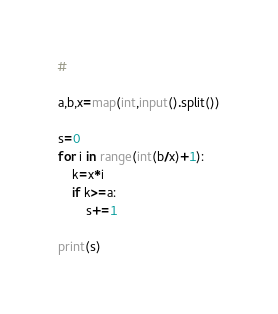Convert code to text. <code><loc_0><loc_0><loc_500><loc_500><_Python_># 

a,b,x=map(int,input().split())

s=0
for i in range(int(b/x)+1):
    k=x*i
    if k>=a:
        s+=1

print(s)</code> 